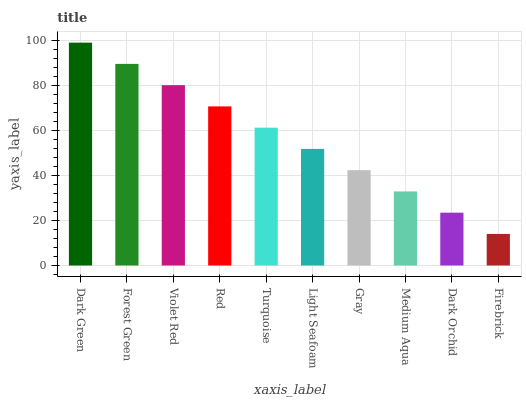Is Forest Green the minimum?
Answer yes or no. No. Is Forest Green the maximum?
Answer yes or no. No. Is Dark Green greater than Forest Green?
Answer yes or no. Yes. Is Forest Green less than Dark Green?
Answer yes or no. Yes. Is Forest Green greater than Dark Green?
Answer yes or no. No. Is Dark Green less than Forest Green?
Answer yes or no. No. Is Turquoise the high median?
Answer yes or no. Yes. Is Light Seafoam the low median?
Answer yes or no. Yes. Is Dark Green the high median?
Answer yes or no. No. Is Dark Orchid the low median?
Answer yes or no. No. 